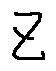Convert formula to latex. <formula><loc_0><loc_0><loc_500><loc_500>z</formula> 